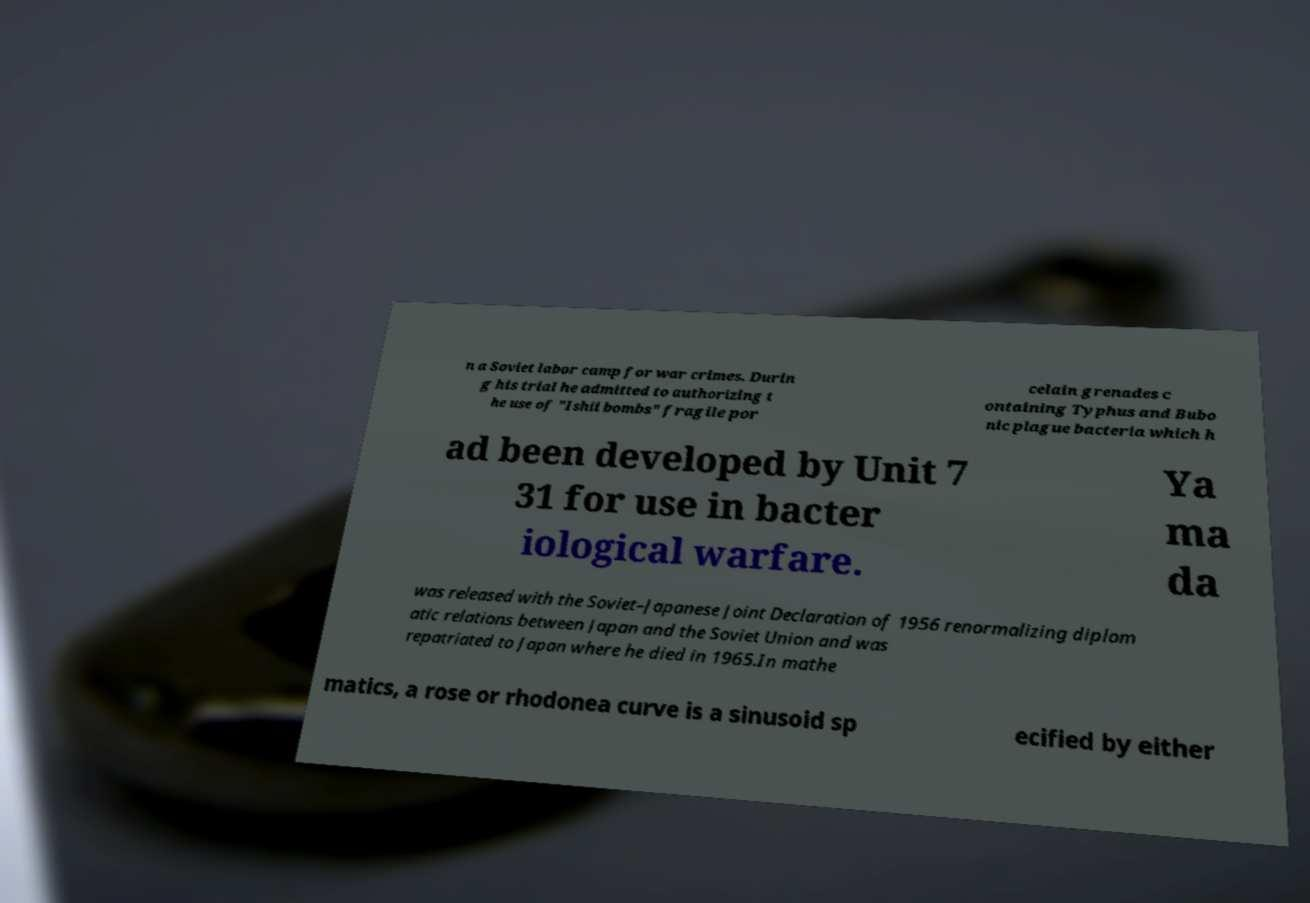There's text embedded in this image that I need extracted. Can you transcribe it verbatim? n a Soviet labor camp for war crimes. Durin g his trial he admitted to authorizing t he use of "Ishii bombs" fragile por celain grenades c ontaining Typhus and Bubo nic plague bacteria which h ad been developed by Unit 7 31 for use in bacter iological warfare. Ya ma da was released with the Soviet–Japanese Joint Declaration of 1956 renormalizing diplom atic relations between Japan and the Soviet Union and was repatriated to Japan where he died in 1965.In mathe matics, a rose or rhodonea curve is a sinusoid sp ecified by either 